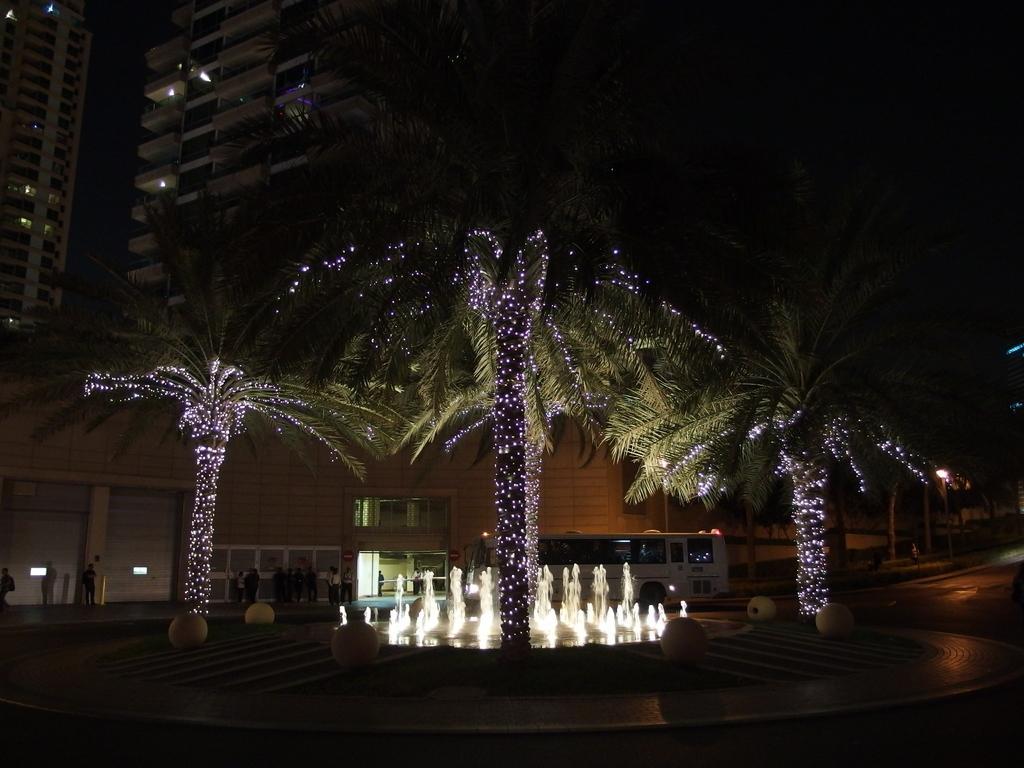How would you summarize this image in a sentence or two? In the center of the image we can see a fountain, trees, lights, bus, some persons are there. On the left side of the image we can see buildings are there. At the bottom of the image ground is present. At the top left corner sky is there. 